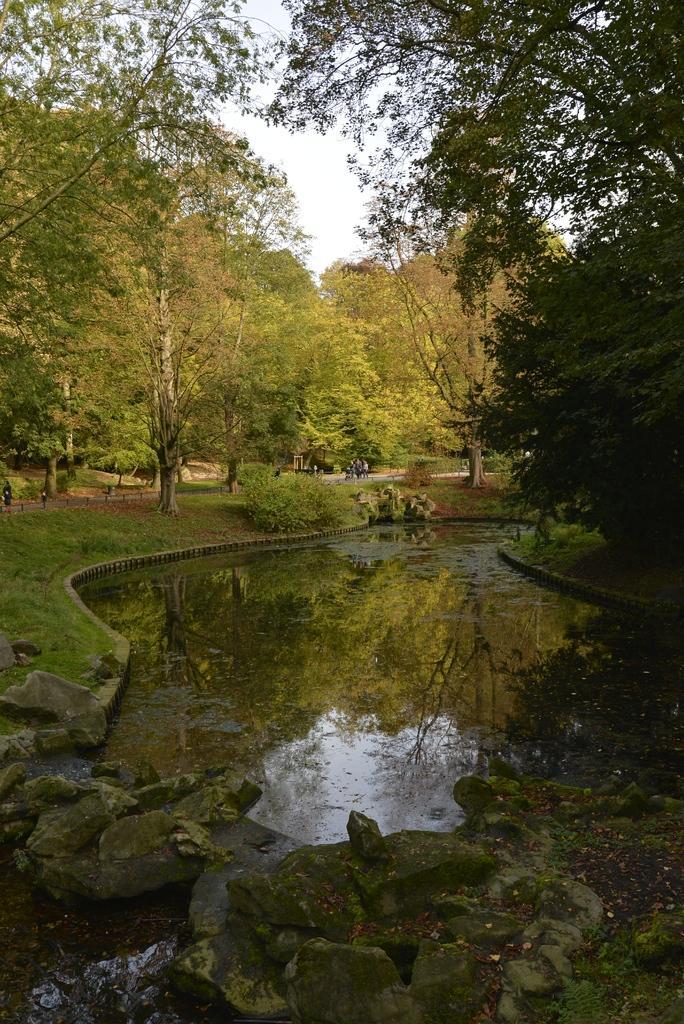How would you summarize this image in a sentence or two? In this image there is the sky towards the top of the image, there are trees, there are plants, there is grass towards the left of the image, there is water, there are rocks towards the bottom of the image. 